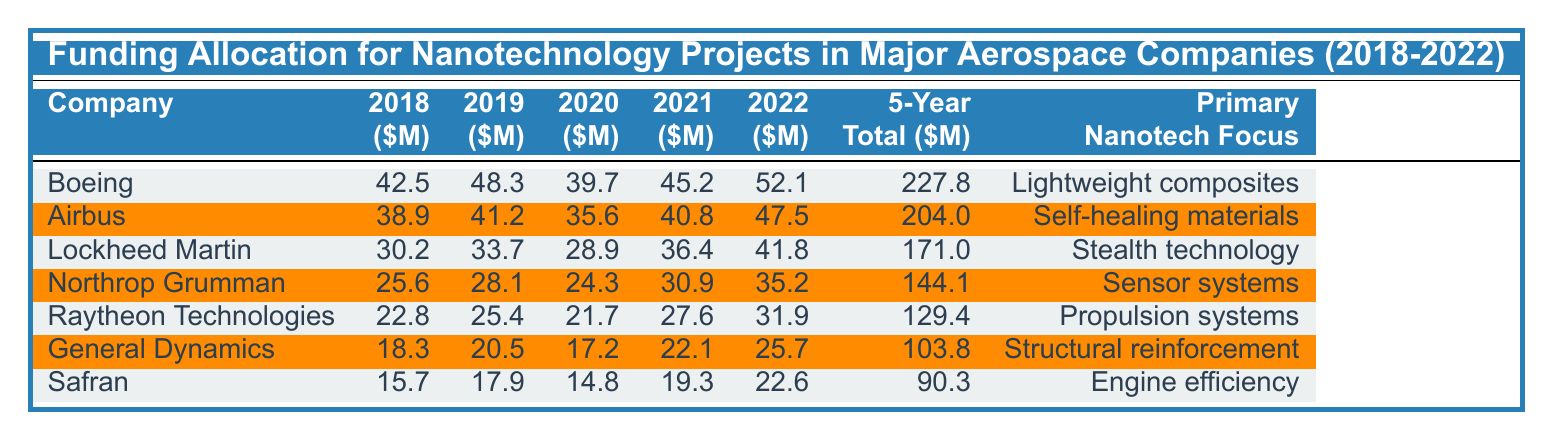What was the total funding allocated to Boeing for nanotechnology projects over the past 5 years? The table states Boeing's 5-Year Total Funding is 227.8 million dollars, which is directly listed in the corresponding column.
Answer: 227.8 million In which year did Airbus receive the highest funding for nanotechnology projects? By checking the funding values for Airbus in each year, the highest amount is in 2022, with 47.5 million dollars.
Answer: 2022 What is the average funding allocated to Lockheed Martin over the 5 years? To find the average, sum the values (30.2 + 33.7 + 28.9 + 36.4 + 41.8 = 171.0) and divide by 5, resulting in an average of 171.0/5 = 34.2 million dollars.
Answer: 34.2 million Did Raytheon Technologies have a total funding greater than 130 million dollars over the 5 years? The total funding for Raytheon Technologies is listed as 129.4 million dollars, which is less than 130 million. So, the answer is no.
Answer: No What is the combined funding for Northrop Grumman and General Dynamics in 2021? For 2021, Northrop Grumman received 30.9 million and General Dynamics received 22.1 million. Adding these values gives 30.9 + 22.1 = 53 million dollars.
Answer: 53 million Which company had the lowest funding allocation in 2018? By comparing the 2018 funding values, Safran received the lowest amount of 15.7 million dollars, as shown in the table.
Answer: Safran What is the percentage increase in the funding for Boeing from 2018 to 2022? Boeing's funding in 2018 was 42.5 million and in 2022 it was 52.1 million. The increase is (52.1 - 42.5 = 9.6). The percentage increase is (9.6/42.5)*100 = 22.6%.
Answer: 22.6% How much more funding did Airbus receive than Raytheon Technologies over the 5 years? Airbus's total funding is 204 million while Raytheon Technologies’ total is 129.4 million. The difference is 204 - 129.4 = 74.6 million dollars.
Answer: 74.6 million Is the primary nanotechnology focus for Safran related to propulsion systems? Safran's primary focus, as stated in the table, is engine efficiency which is different from propulsion systems. Thus, the answer is no.
Answer: No 